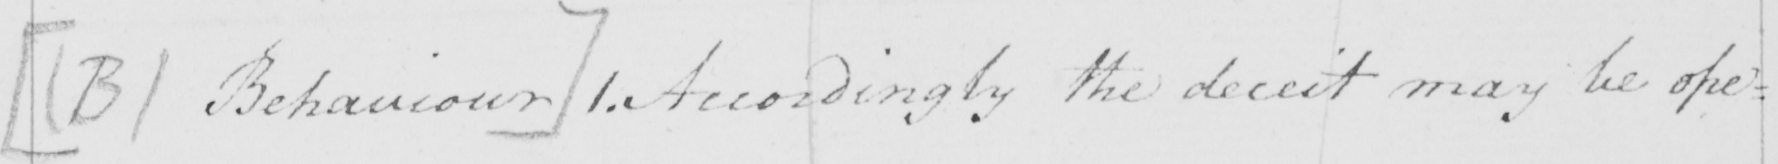Please transcribe the handwritten text in this image. [  ( B )  Behaviour ]  1 . Accordingly the deceit may be ope= 